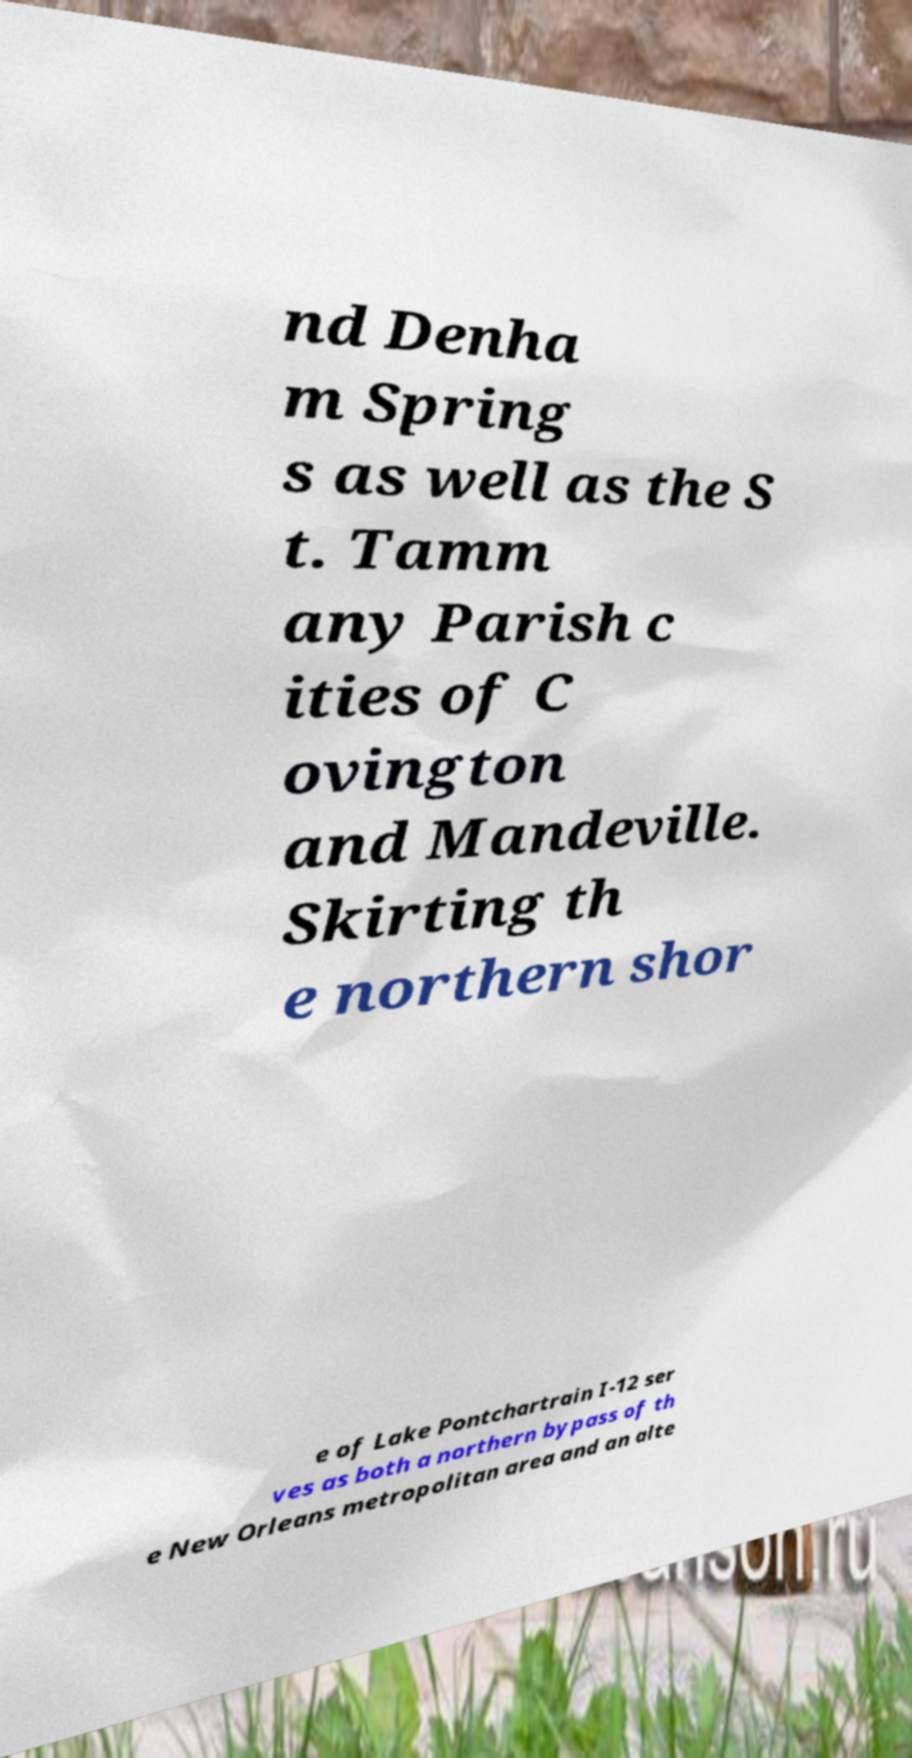For documentation purposes, I need the text within this image transcribed. Could you provide that? nd Denha m Spring s as well as the S t. Tamm any Parish c ities of C ovington and Mandeville. Skirting th e northern shor e of Lake Pontchartrain I-12 ser ves as both a northern bypass of th e New Orleans metropolitan area and an alte 